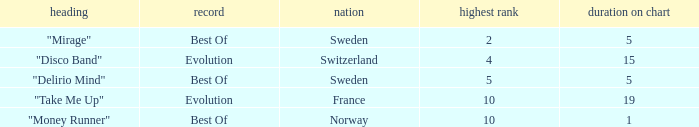What is the title of the single with the peak position of 10 and weeks on chart is less than 19? "Money Runner". 